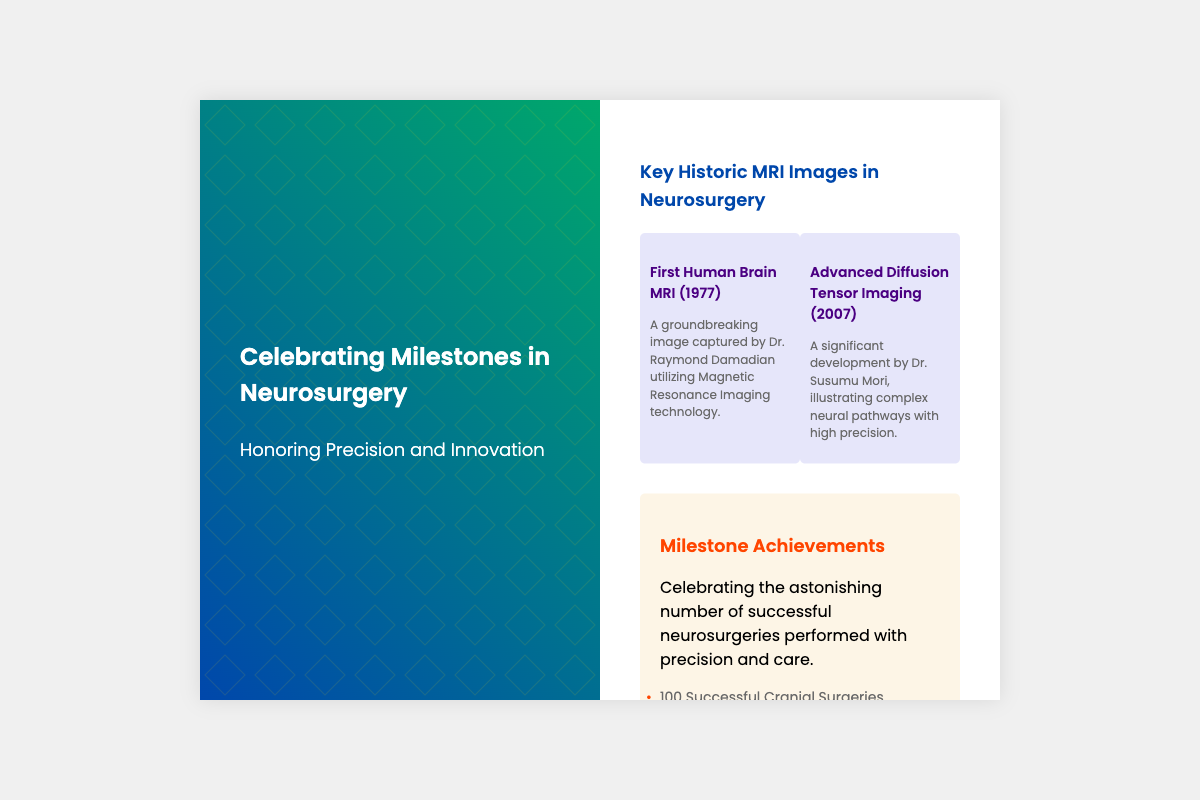What is the title of the card? The title of the card is prominently displayed at the top, stating its purpose and theme.
Answer: Celebrating Milestones in Neurosurgery Who is honored in the card? The card celebrates achievements in a specialized medical field, emphasizing skill and innovation.
Answer: Precision and Innovation What year was the first human brain MRI captured? The document includes historical milestones that specify key dates for significant events in neurosurgery.
Answer: 1977 How many successful cranial surgeries are celebrated? The card lists milestone achievements, including the total successful cranial surgeries performed.
Answer: 100 What kind of surgeries does the card highlight? The card provides details about specific types of surgeries performed, showcasing a variety of achievements.
Answer: Neurosurgeries 